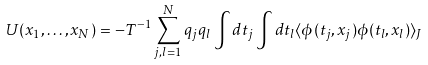Convert formula to latex. <formula><loc_0><loc_0><loc_500><loc_500>U ( { x } _ { 1 } , \dots , { x } _ { N } ) = - T ^ { - 1 } \sum _ { j , l = 1 } ^ { N } q _ { j } q _ { l } \int d t _ { j } \int d t _ { l } \langle \phi ( t _ { j } , { x } _ { j } ) \phi ( t _ { l } , { x } _ { l } ) \rangle _ { J }</formula> 